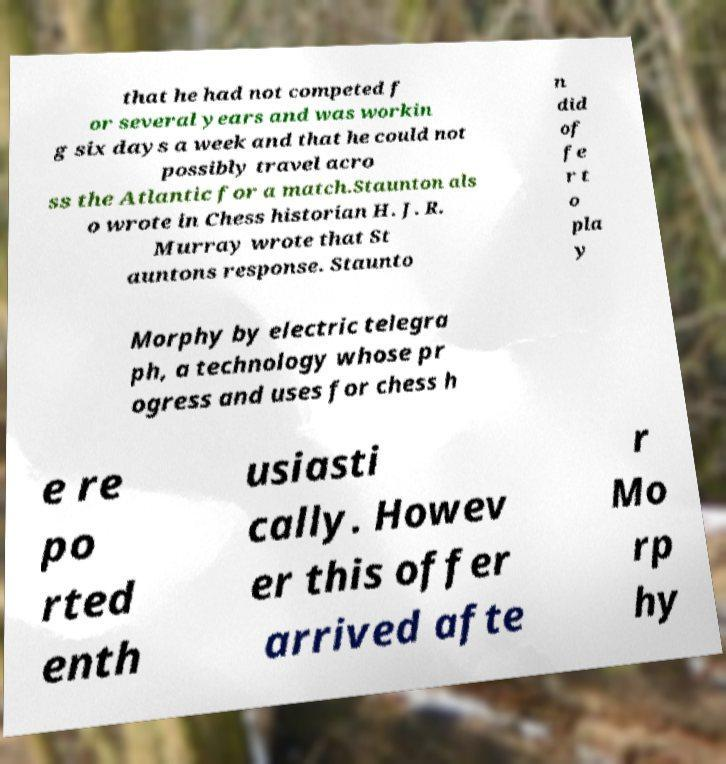Could you assist in decoding the text presented in this image and type it out clearly? that he had not competed f or several years and was workin g six days a week and that he could not possibly travel acro ss the Atlantic for a match.Staunton als o wrote in Chess historian H. J. R. Murray wrote that St auntons response. Staunto n did of fe r t o pla y Morphy by electric telegra ph, a technology whose pr ogress and uses for chess h e re po rted enth usiasti cally. Howev er this offer arrived afte r Mo rp hy 